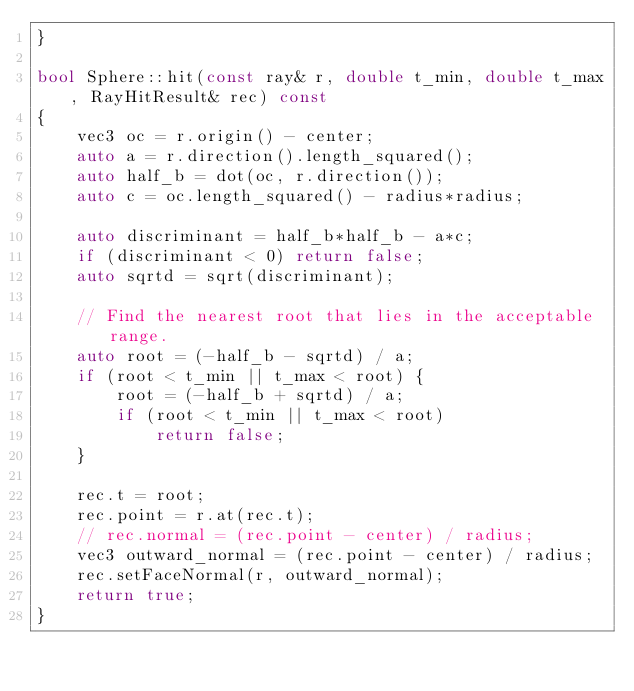Convert code to text. <code><loc_0><loc_0><loc_500><loc_500><_C++_>}

bool Sphere::hit(const ray& r, double t_min, double t_max, RayHitResult& rec) const
{
    vec3 oc = r.origin() - center;
    auto a = r.direction().length_squared();
    auto half_b = dot(oc, r.direction());
    auto c = oc.length_squared() - radius*radius;

    auto discriminant = half_b*half_b - a*c;
    if (discriminant < 0) return false;
    auto sqrtd = sqrt(discriminant);

    // Find the nearest root that lies in the acceptable range.
    auto root = (-half_b - sqrtd) / a;
    if (root < t_min || t_max < root) {
        root = (-half_b + sqrtd) / a;
        if (root < t_min || t_max < root)
            return false;
    }

    rec.t = root;
    rec.point = r.at(rec.t);
    // rec.normal = (rec.point - center) / radius;
    vec3 outward_normal = (rec.point - center) / radius;
    rec.setFaceNormal(r, outward_normal);
    return true;
}</code> 